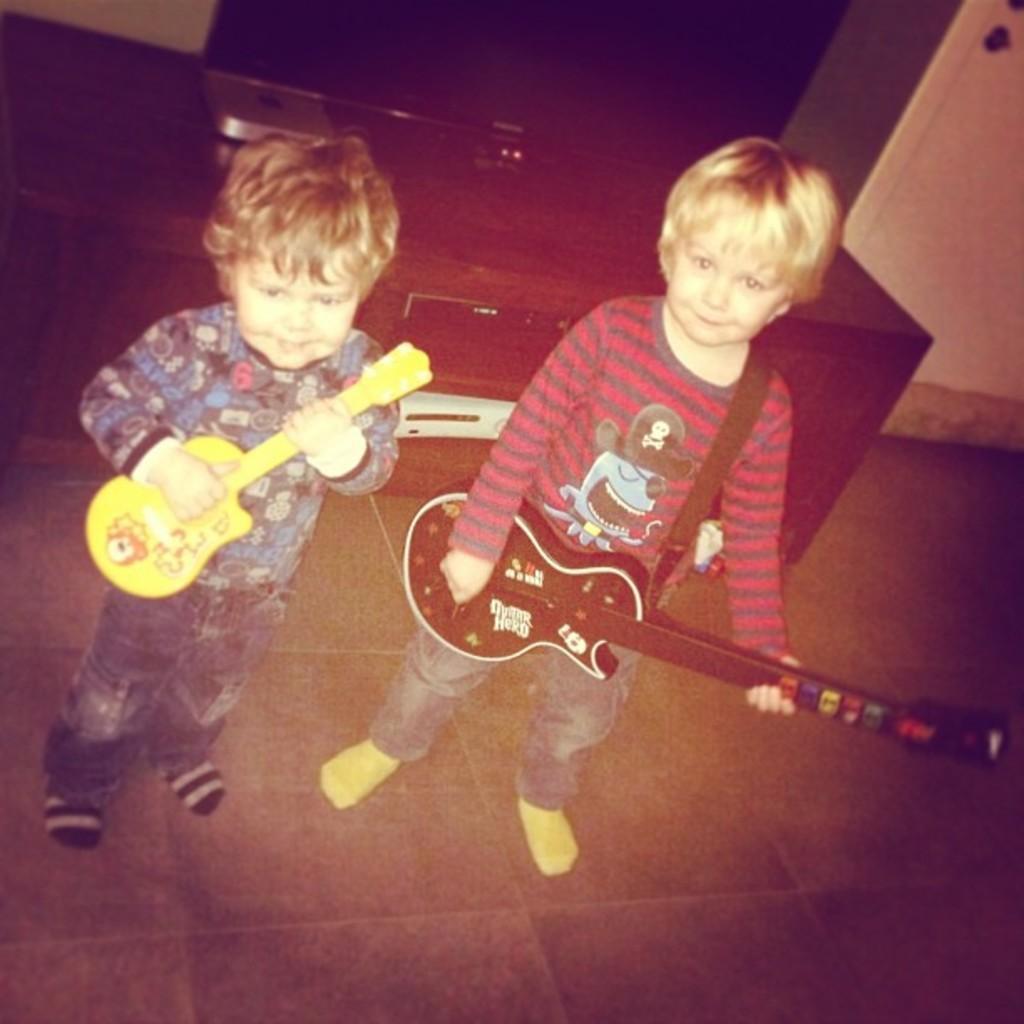Please provide a concise description of this image. There are two kids in the image, they are holding the guitar. There is a television on the table at the back of the kids. 